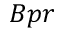<formula> <loc_0><loc_0><loc_500><loc_500>B p r</formula> 